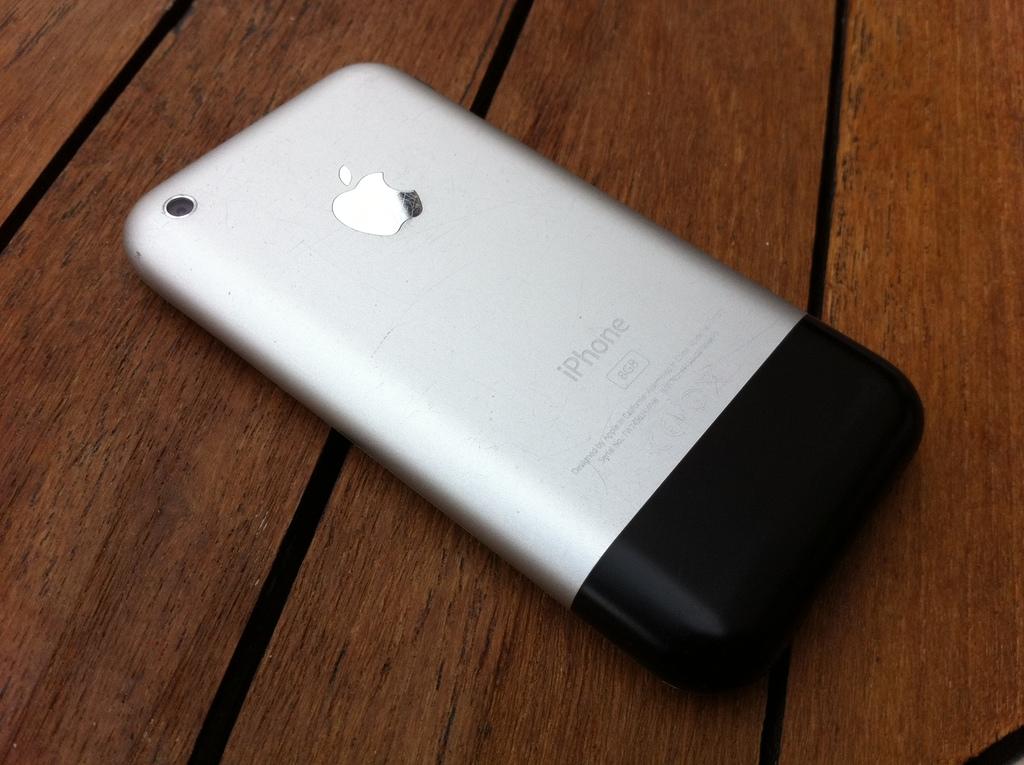What brand is the phone?
Your response must be concise. Iphone. How many gigabytes does the iphone have?
Ensure brevity in your answer.  8. 